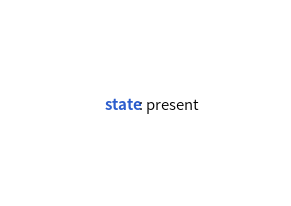Convert code to text. <code><loc_0><loc_0><loc_500><loc_500><_YAML_>    state: present
</code> 